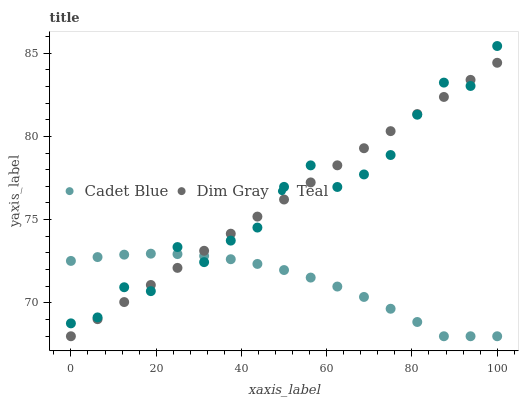Does Cadet Blue have the minimum area under the curve?
Answer yes or no. Yes. Does Dim Gray have the maximum area under the curve?
Answer yes or no. Yes. Does Teal have the minimum area under the curve?
Answer yes or no. No. Does Teal have the maximum area under the curve?
Answer yes or no. No. Is Dim Gray the smoothest?
Answer yes or no. Yes. Is Teal the roughest?
Answer yes or no. Yes. Is Cadet Blue the smoothest?
Answer yes or no. No. Is Cadet Blue the roughest?
Answer yes or no. No. Does Dim Gray have the lowest value?
Answer yes or no. Yes. Does Teal have the lowest value?
Answer yes or no. No. Does Teal have the highest value?
Answer yes or no. Yes. Does Cadet Blue have the highest value?
Answer yes or no. No. Does Dim Gray intersect Cadet Blue?
Answer yes or no. Yes. Is Dim Gray less than Cadet Blue?
Answer yes or no. No. Is Dim Gray greater than Cadet Blue?
Answer yes or no. No. 